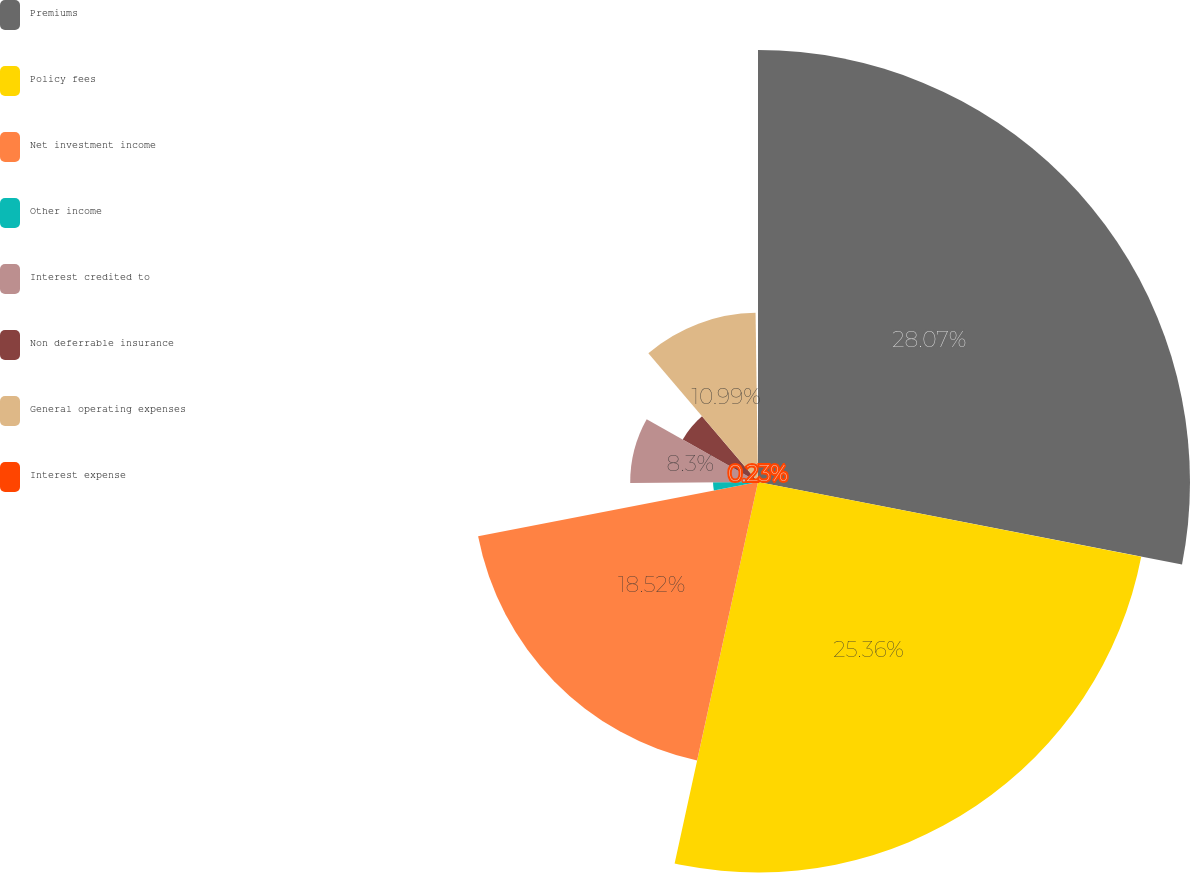<chart> <loc_0><loc_0><loc_500><loc_500><pie_chart><fcel>Premiums<fcel>Policy fees<fcel>Net investment income<fcel>Other income<fcel>Interest credited to<fcel>Non deferrable insurance<fcel>General operating expenses<fcel>Interest expense<nl><fcel>28.06%<fcel>25.36%<fcel>18.52%<fcel>2.92%<fcel>8.3%<fcel>5.61%<fcel>10.99%<fcel>0.23%<nl></chart> 